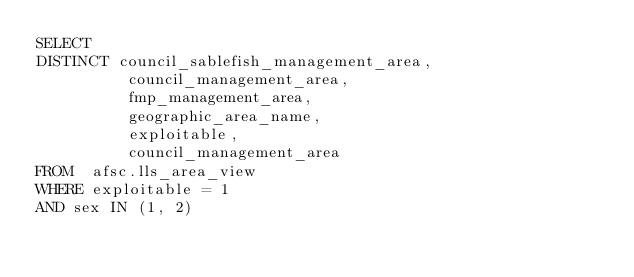Convert code to text. <code><loc_0><loc_0><loc_500><loc_500><_SQL_>SELECT
DISTINCT council_sablefish_management_area,
          council_management_area,
          fmp_management_area,
          geographic_area_name,
          exploitable,
          council_management_area
FROM  afsc.lls_area_view
WHERE exploitable = 1
AND sex IN (1, 2)
</code> 